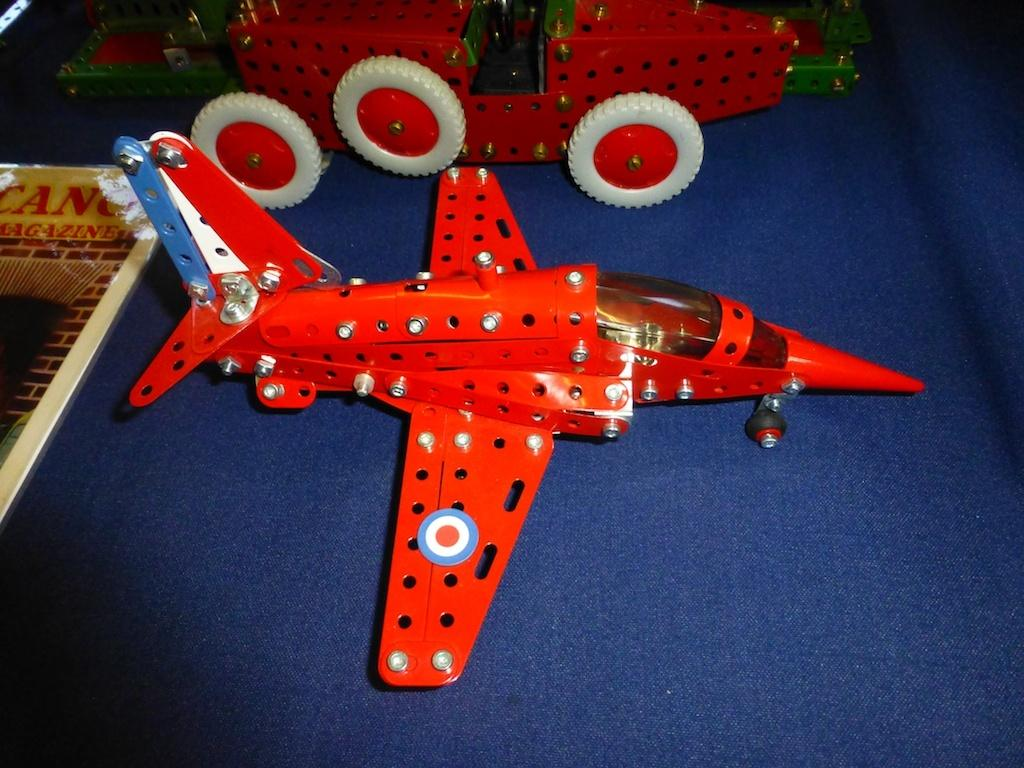What type of toy is present in the image? There is a toy aircraft in the image. What other object can be seen in the image? There is a vehicle in the image. Can you describe any other item in the image? There appears to be a poster in the image. What type of snails can be seen crawling on the toy aircraft in the image? There are no snails present in the image, so it is not possible to answer that question. 